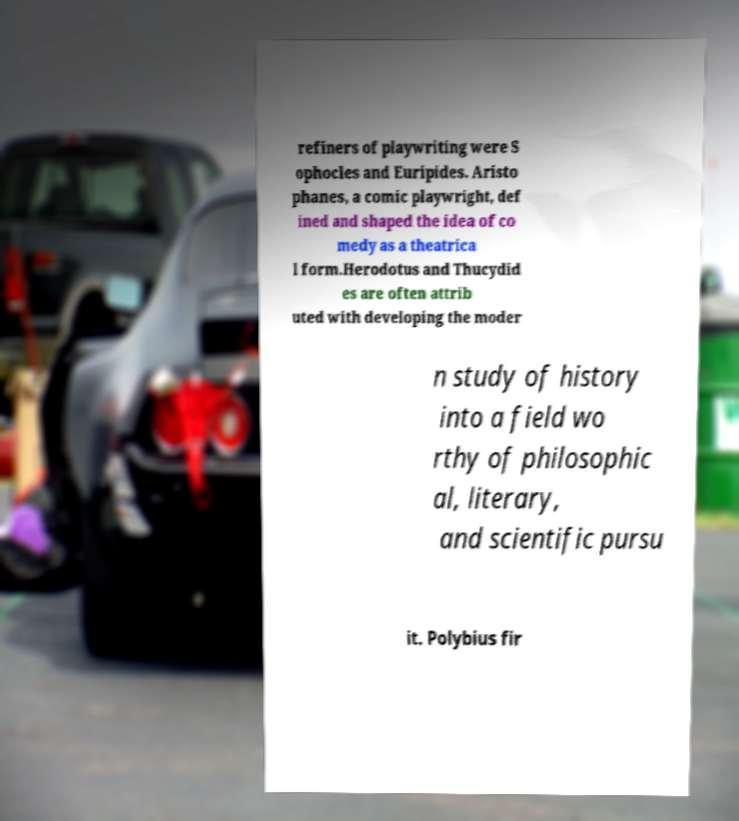Could you assist in decoding the text presented in this image and type it out clearly? refiners of playwriting were S ophocles and Euripides. Aristo phanes, a comic playwright, def ined and shaped the idea of co medy as a theatrica l form.Herodotus and Thucydid es are often attrib uted with developing the moder n study of history into a field wo rthy of philosophic al, literary, and scientific pursu it. Polybius fir 